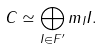Convert formula to latex. <formula><loc_0><loc_0><loc_500><loc_500>C \simeq \bigoplus _ { I \in F ^ { \prime } } m _ { I } I .</formula> 